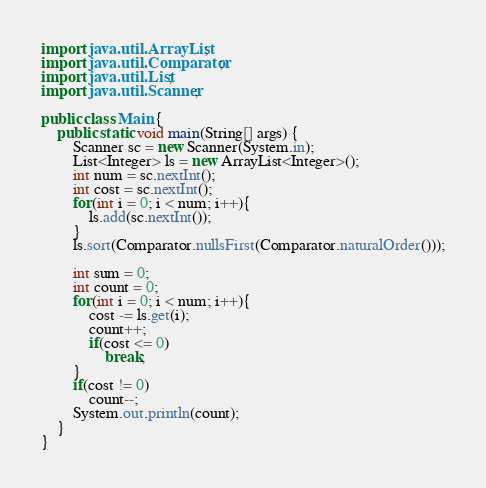Convert code to text. <code><loc_0><loc_0><loc_500><loc_500><_Java_>import java.util.ArrayList;
import java.util.Comparator;
import java.util.List;
import java.util.Scanner;

public class Main {
    public static void main(String[] args) {
        Scanner sc = new Scanner(System.in);
        List<Integer> ls = new ArrayList<Integer>();
        int num = sc.nextInt();
        int cost = sc.nextInt();
        for(int i = 0; i < num; i++){
            ls.add(sc.nextInt());
        }
        ls.sort(Comparator.nullsFirst(Comparator.naturalOrder()));

        int sum = 0;
        int count = 0;
        for(int i = 0; i < num; i++){
            cost -= ls.get(i);
            count++;
            if(cost <= 0)
                break;
        }
        if(cost != 0)
            count--;
        System.out.println(count);
    }
}</code> 